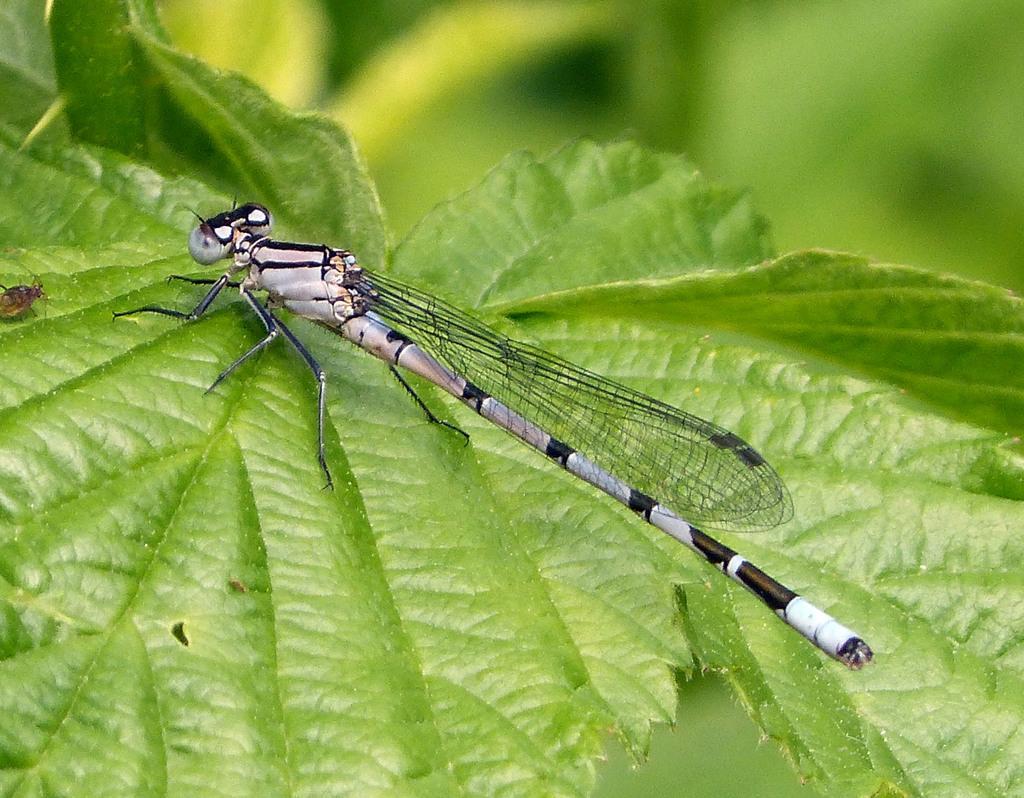Could you give a brief overview of what you see in this image? In this picture we can see a coenagrion which is present on a leaf, we can see a blurry background. 